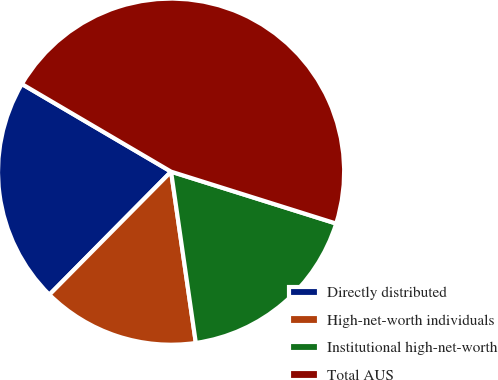Convert chart to OTSL. <chart><loc_0><loc_0><loc_500><loc_500><pie_chart><fcel>Directly distributed<fcel>High-net-worth individuals<fcel>Institutional high-net-worth<fcel>Total AUS<nl><fcel>21.04%<fcel>14.7%<fcel>17.87%<fcel>46.4%<nl></chart> 